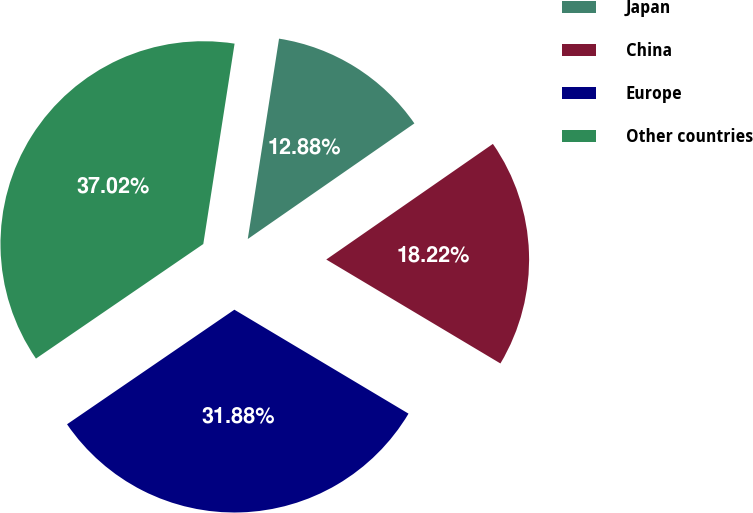<chart> <loc_0><loc_0><loc_500><loc_500><pie_chart><fcel>Japan<fcel>China<fcel>Europe<fcel>Other countries<nl><fcel>12.88%<fcel>18.22%<fcel>31.88%<fcel>37.02%<nl></chart> 